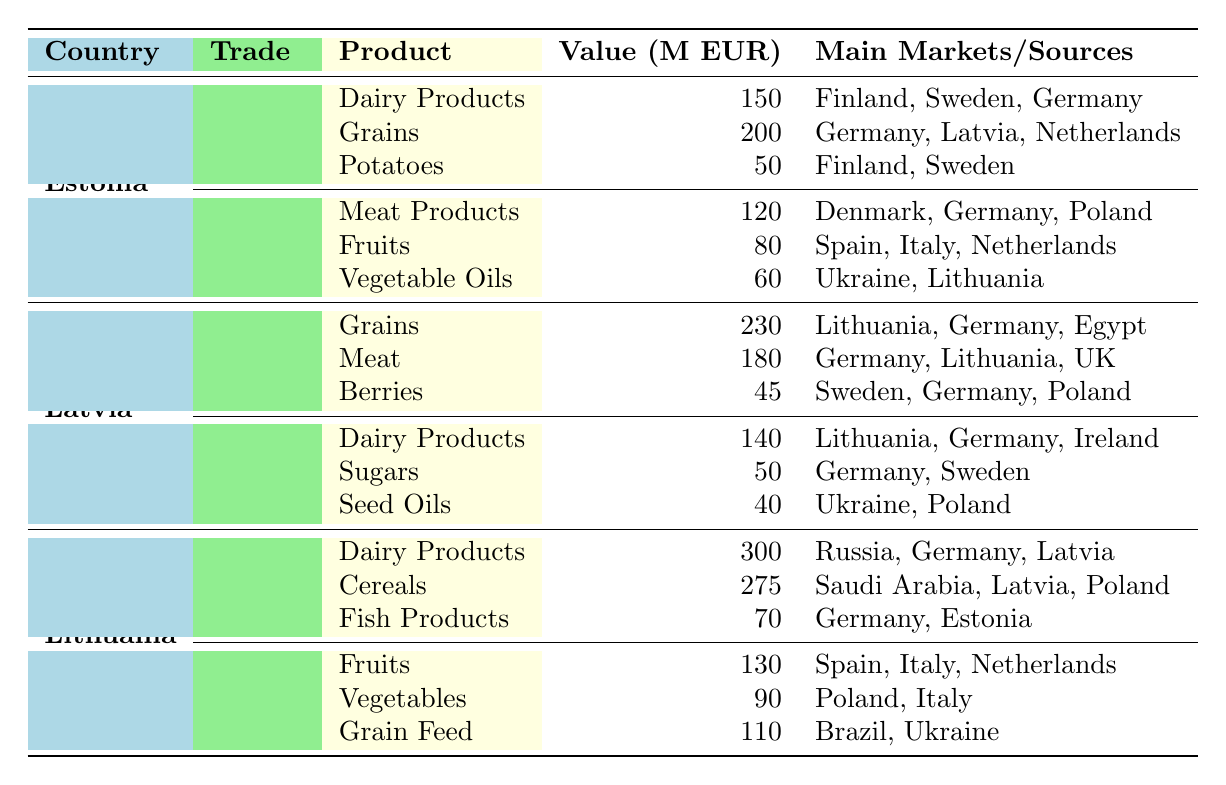What is the total export value of dairy products from Lithuania? The table shows that Lithuania exports dairy products valued at 300 million EUR. Since there are no other dairy products listed for Lithuania, the total export value for this category is simply 300 million EUR.
Answer: 300 million EUR Which Baltic State exports the most grains? From the table, Estonia exports grains valued at 200 million EUR, Latvia exports grains valued at 230 million EUR, and Lithuania exports cereals valued at 275 million EUR. Comparing these values indicates that Latvia, with 230 million EUR, exports the most grains among the three states.
Answer: Latvia Are vegetable oils imported by Estonia? The table indicates that Estonia imports vegetable oils valued at 60 million EUR. Hence, the answer is yes, they do import vegetable oils.
Answer: Yes What is the total import value for Latvia? To find the total import value for Latvia, sum the value of all imports: 140 (Dairy Products) + 50 (Sugars) + 40 (Seed Oils) = 230 million EUR. Therefore, the total import value for Latvia is 230 million EUR.
Answer: 230 million EUR Which products does Lithuania import from Spain? The table shows that Lithuania imports fruits valued at 130 million EUR from Spain. There are no other products listed under imports from Spain for Lithuania. Therefore, the only product imported from Spain is fruits.
Answer: Fruits What is the difference between the highest and lowest export values for Estonia? Estonia's highest export value is 200 million EUR for grains and the lowest is 50 million EUR for potatoes. To find the difference: 200 million EUR - 50 million EUR = 150 million EUR. Thus, the difference is 150 million EUR.
Answer: 150 million EUR Is it true that Latvia exports more meat than Estonia? Latvia exports meat valued at 180 million EUR, while Estonia's exports for meat products are not listed, but they import meat products valued at 120 million EUR. Since exports are not specified as being higher, it is ambiguous but likely true since we do not have an export data point for Estonia's meat.
Answer: True What percentage of Lithuania's exports is accounted for by dairy products? Lithuania's total export value can be found by summing its exports: 300 (Dairy Products) + 275 (Cereals) + 70 (Fish Products) = 645 million EUR. The dairy products contribute 300 million EUR, so the percentage is (300 / 645) * 100 = approximately 46.51%. Therefore, dairy products account for about 46.51% of Lithuania's total exports.
Answer: 46.51% 